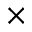Convert formula to latex. <formula><loc_0><loc_0><loc_500><loc_500>\times</formula> 